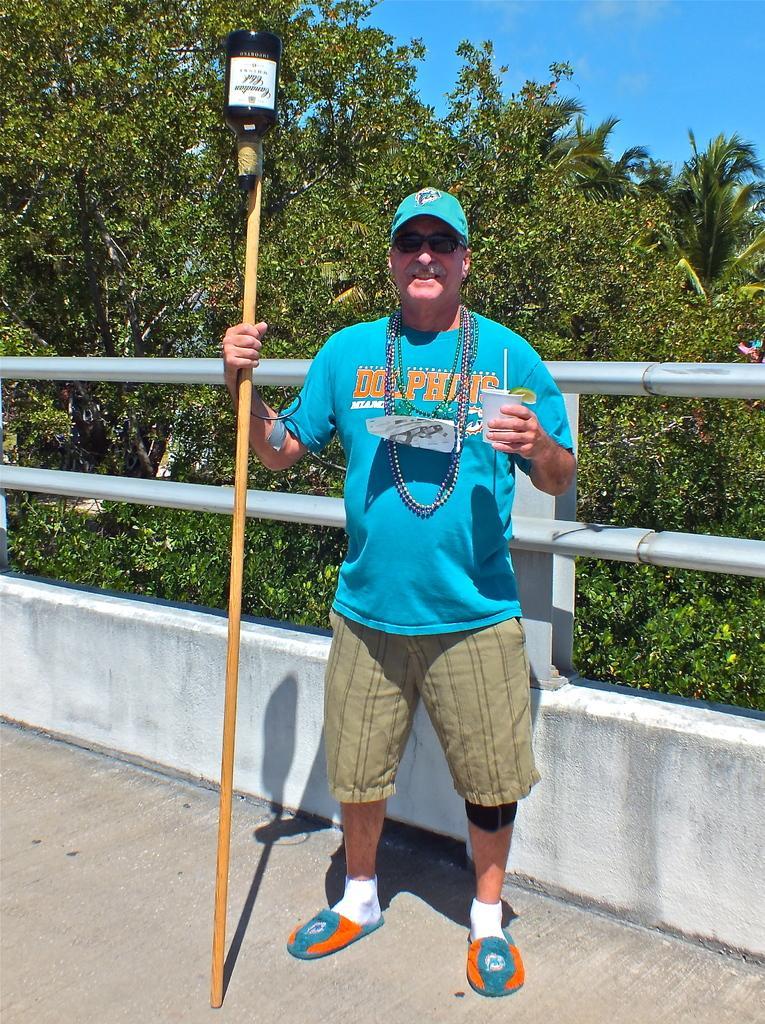In one or two sentences, can you explain what this image depicts? In this image, I can see a person standing and holding a cup and stick with a bottle. Behind the man, there is a railing on the wall. In the background, there are trees and the sky. 